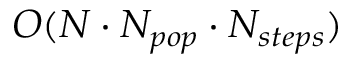Convert formula to latex. <formula><loc_0><loc_0><loc_500><loc_500>O ( N \cdot N _ { p o p } \cdot N _ { s t e p s } )</formula> 